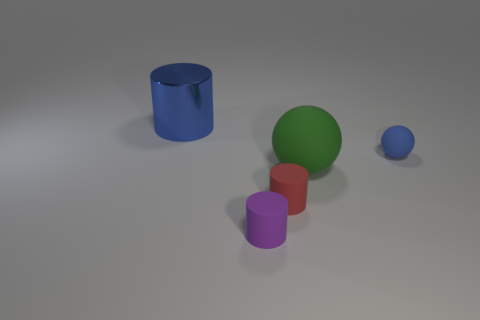Are there any shadows visible in the image, and what do they tell us about the light source? Yes, there are shadows cast by each object on the ground, indicating that the light source is positioned above and slightly to the front of them. The shadows are soft and diffuse, suggesting a larger light source, such as a softbox or overcast sky. Can you determine the time of day if this were an outdoor setting? If this were an outdoor setting, the diffuse nature of the shadows might imply an overcast day, which does not provide enough clues to accurately determine the time of day without further context. 